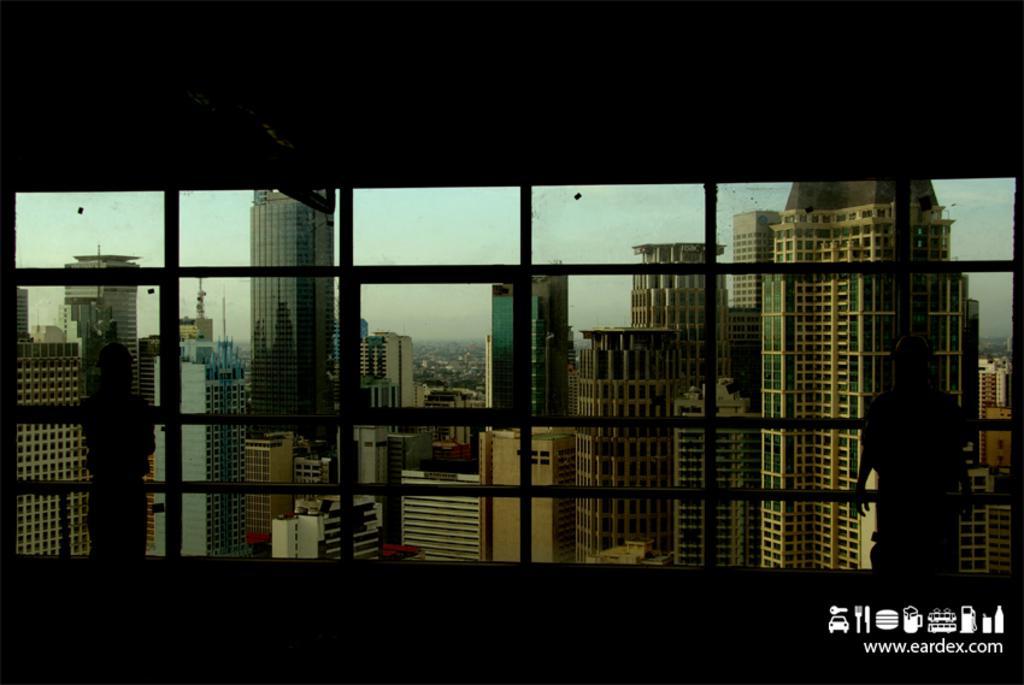How would you summarize this image in a sentence or two? As we can see in the image there are buildings, sky and a person standing on the right side. The image is little dark. 